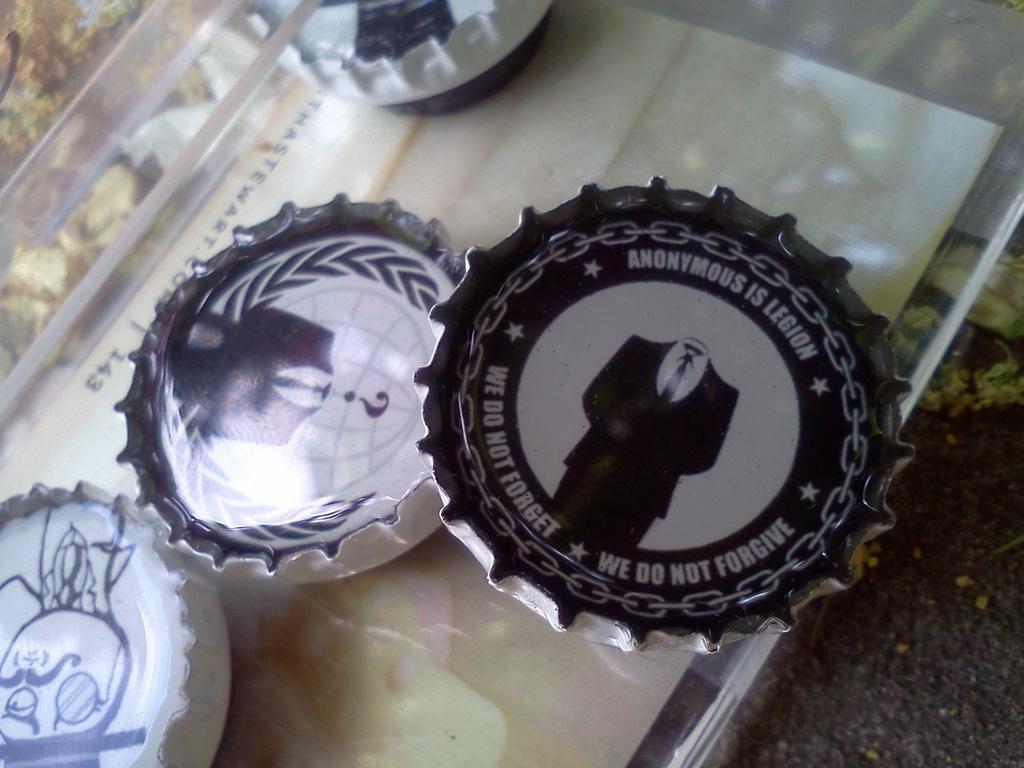Please provide a concise description of this image. In this image I can see four bottle crowns with some images below the crown on a glass plate. 